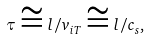Convert formula to latex. <formula><loc_0><loc_0><loc_500><loc_500>\tau \cong l / v _ { i T } \cong l / c _ { s } ,</formula> 